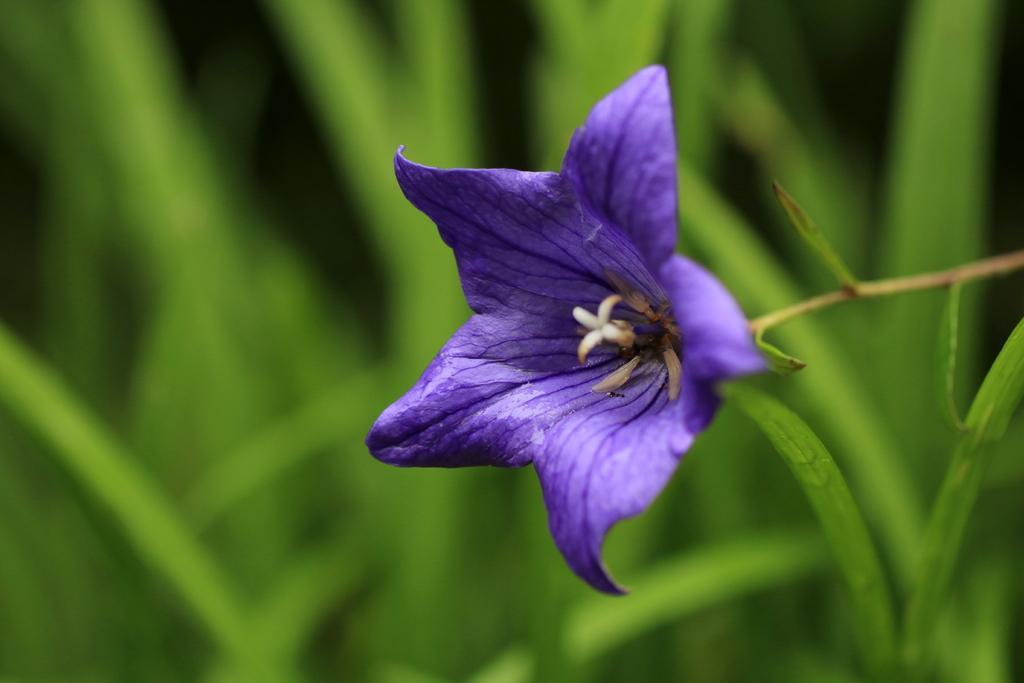In one or two sentences, can you explain what this image depicts? In this image we can see a violet color flower on stem. In the background it is green and blur. 